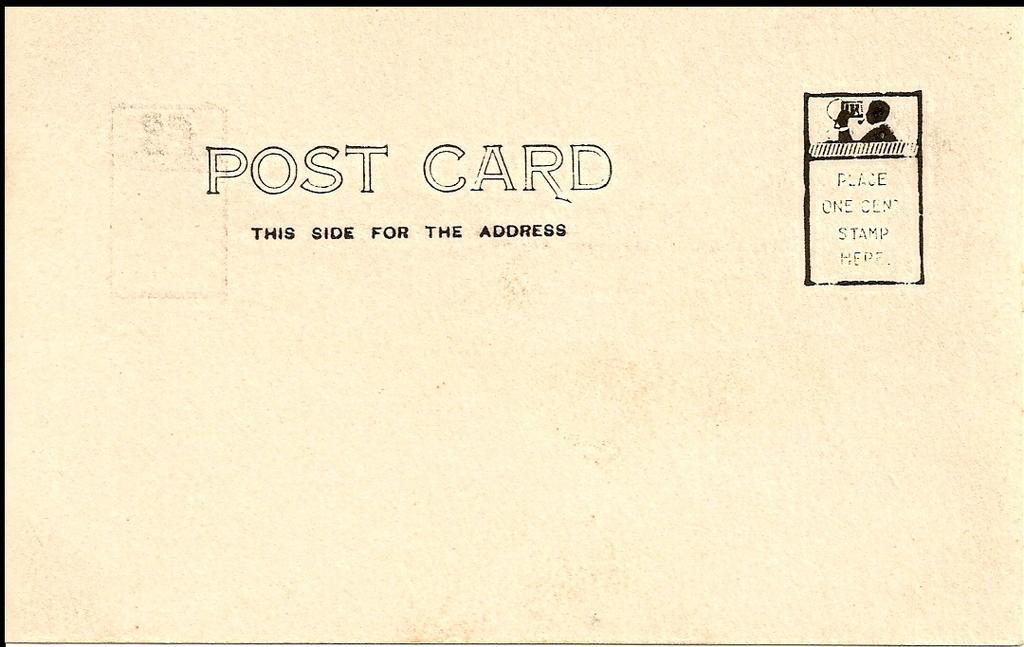Can you describe this image briefly? In the image there is a postcard with some text on it. 